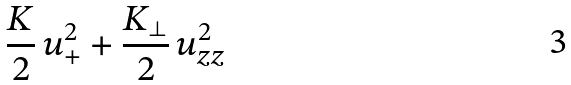Convert formula to latex. <formula><loc_0><loc_0><loc_500><loc_500>\frac { K } { 2 } \, u _ { + } ^ { 2 } + \frac { K _ { \perp } } { 2 } \, u _ { z z } ^ { 2 }</formula> 